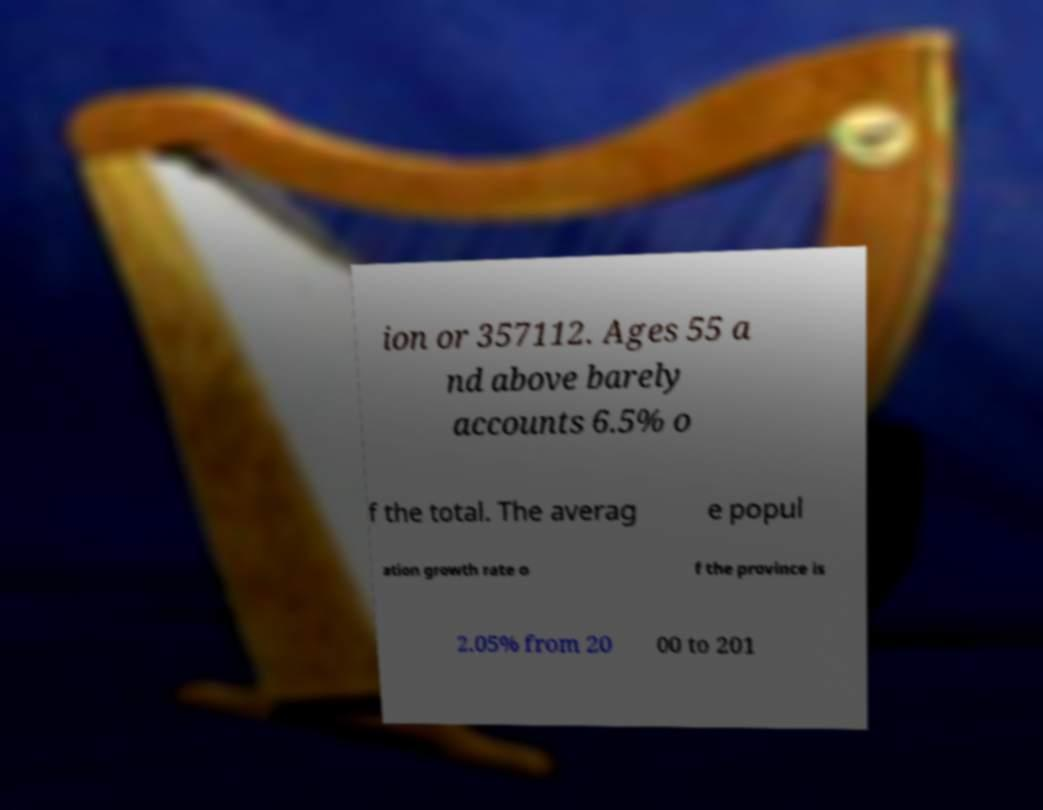Please identify and transcribe the text found in this image. ion or 357112. Ages 55 a nd above barely accounts 6.5% o f the total. The averag e popul ation growth rate o f the province is 2.05% from 20 00 to 201 